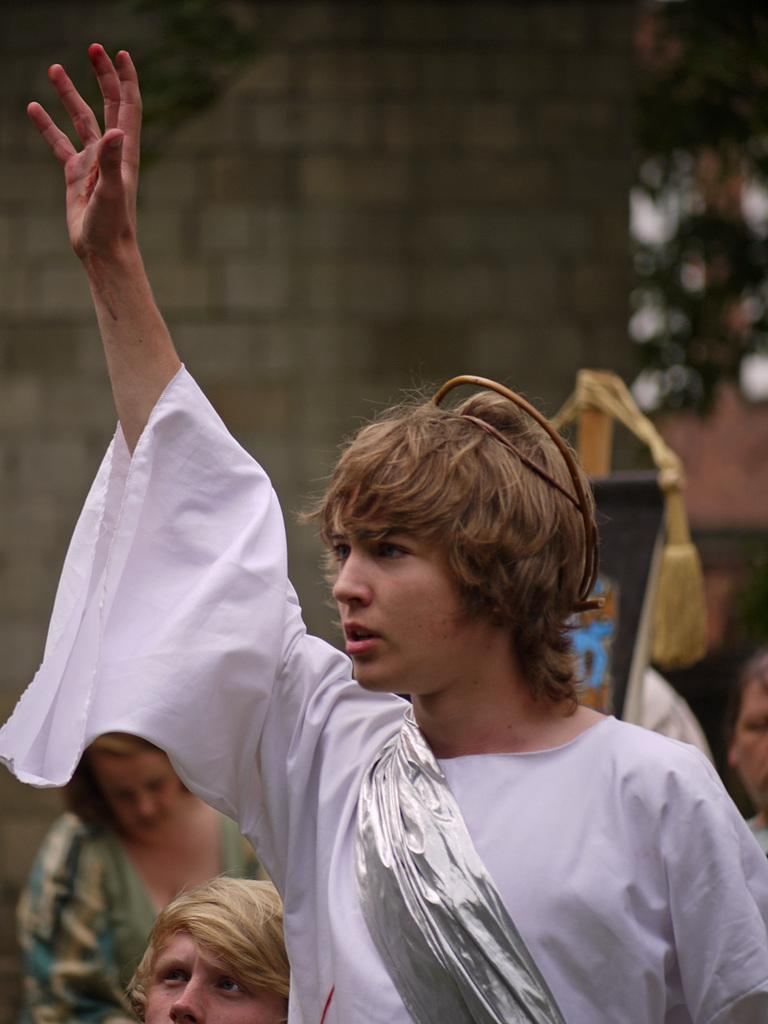What is the main subject of the image? There is a man standing in the image. Can you describe the man's attire? The man is wearing a fancy dress. Who else is present in the image? There is a woman and a boy standing in the image. What object can be seen in the image? There appears to be a board in the image. How would you describe the background of the image? The background of the image looks blurry. What type of plot is being discussed by the characters in the image? There is no indication of a plot or conversation taking place in the image; it simply shows a man, a woman, and a boy standing near a board. What color is the light beam emanating from the board in the image? There is no light beam present in the image; it only shows a man, a woman, a boy, and a board. 